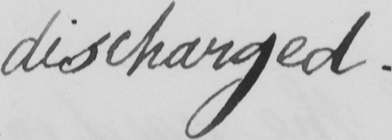Can you read and transcribe this handwriting? discharged . 